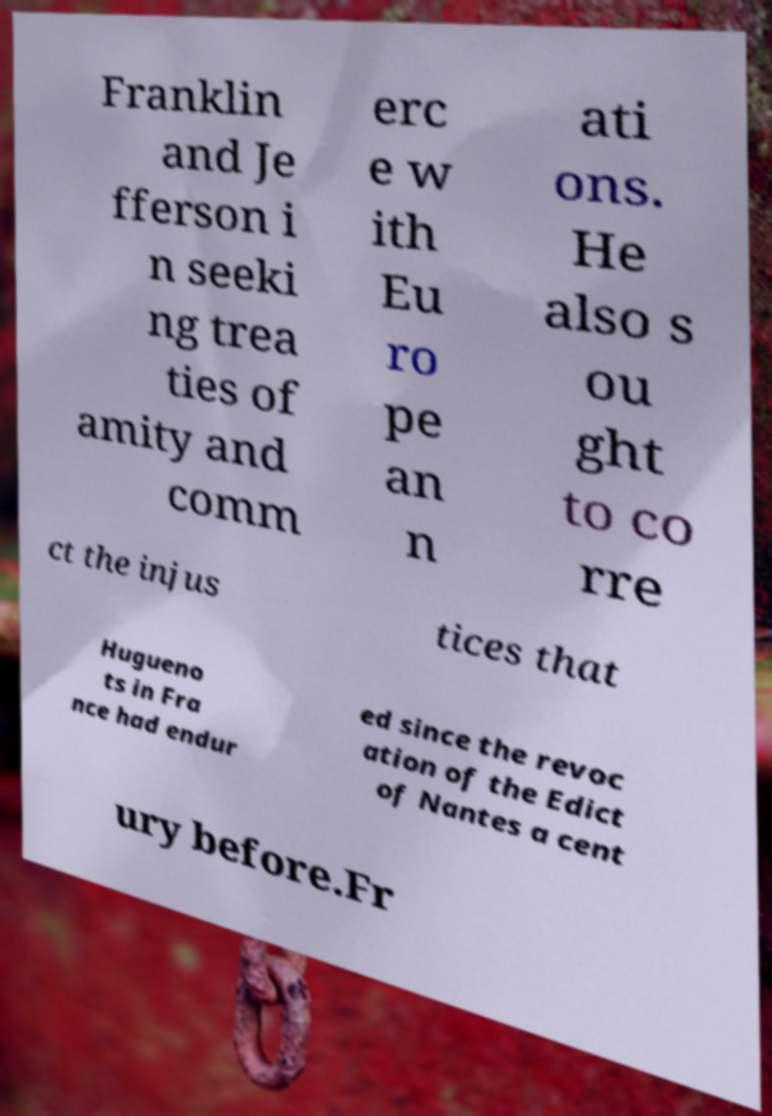What messages or text are displayed in this image? I need them in a readable, typed format. Franklin and Je fferson i n seeki ng trea ties of amity and comm erc e w ith Eu ro pe an n ati ons. He also s ou ght to co rre ct the injus tices that Hugueno ts in Fra nce had endur ed since the revoc ation of the Edict of Nantes a cent ury before.Fr 